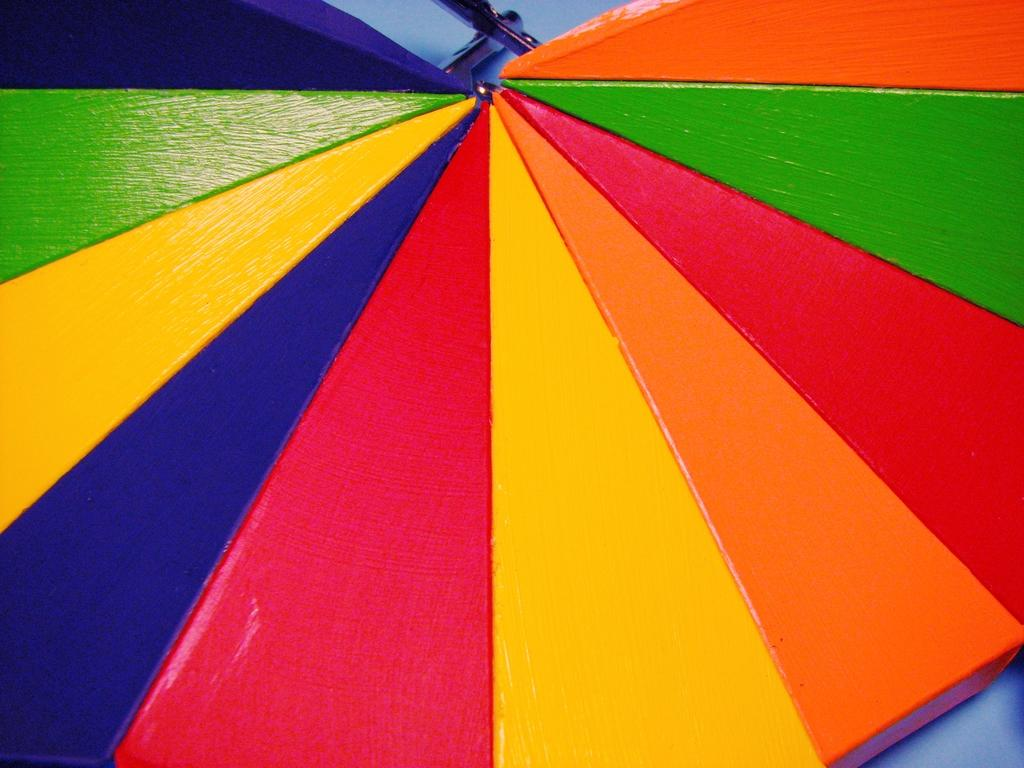What can be observed about the objects in the image in terms of color? There are multiple colored objects in the image. Can you describe the variety of colors present in the image? The colors of the objects in the image cannot be determined without more specific information about the image. What type of suit is the person wearing in the image? There is no person or suit present in the image; it only contains multiple colored objects. 